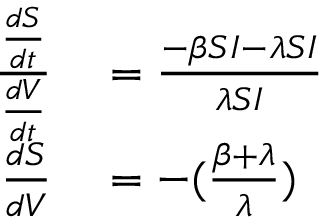Convert formula to latex. <formula><loc_0><loc_0><loc_500><loc_500>\begin{array} { r l } { \frac { \frac { d S } { d t } } { \frac { d V } { d t } } } & = \frac { - \beta S I - \lambda S I } { \lambda S I } } \\ { { \frac { d S } { d V } } } & = - ( \frac { \beta + \lambda } { \lambda } ) } \end{array}</formula> 